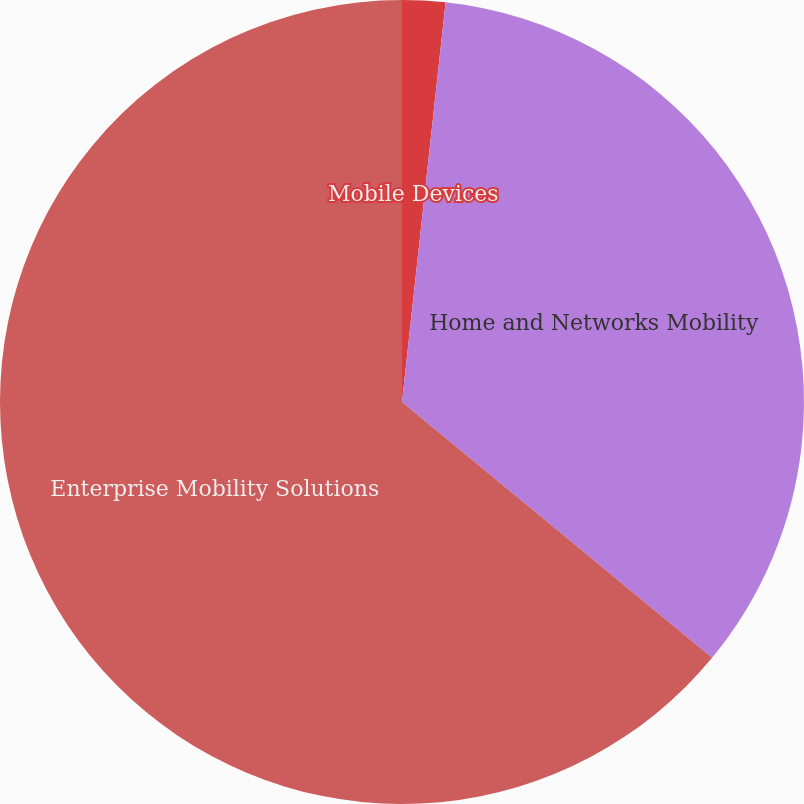Convert chart to OTSL. <chart><loc_0><loc_0><loc_500><loc_500><pie_chart><fcel>Mobile Devices<fcel>Home and Networks Mobility<fcel>Enterprise Mobility Solutions<nl><fcel>1.73%<fcel>34.25%<fcel>64.02%<nl></chart> 